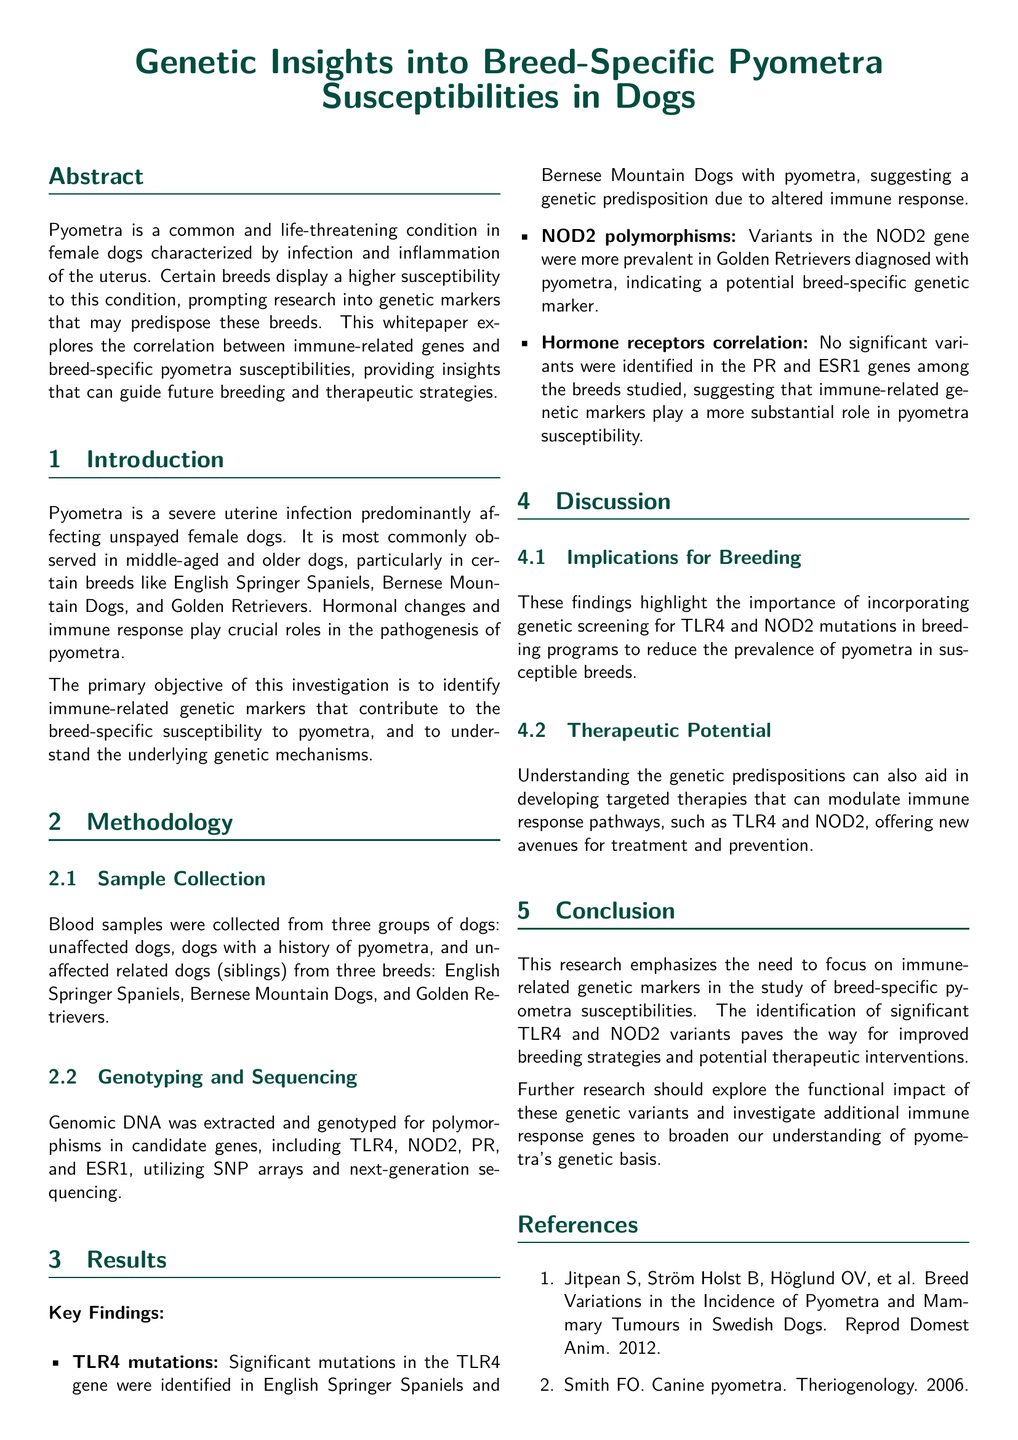What is the condition characterized by infection and inflammation of the uterus? The document describes pyometra as the common condition affecting female dogs characterized by infection and inflammation of the uterus.
Answer: Pyometra Which breeds are specifically mentioned as having a higher susceptibility to pyometra? The breeds highlighted for their higher susceptibility to pyometra are English Springer Spaniels, Bernese Mountain Dogs, and Golden Retrievers.
Answer: English Springer Spaniels, Bernese Mountain Dogs, Golden Retrievers What are the two immune-related genes identified with significant mutations associated with pyometra? The key findings mention TLR4 and NOD2 genes with significant mutations linked to pyometra susceptibility in certain breeds.
Answer: TLR4, NOD2 What type of genetic variations were found in Golden Retrievers diagnosed with pyometra? The results state that variants in the NOD2 gene were more prevalent among Golden Retrievers with pyometra, indicating its role as a potential genetic marker.
Answer: Variants in the NOD2 gene What does the research imply about the genetic screening of certain mutations? The discussion highlights that the findings support incorporating genetic screening for TLR4 and NOD2 mutations in breeding programs to reduce pyometra prevalence.
Answer: Genetic screening for TLR4 and NOD2 mutations What is the primary objective of the investigation? The primary objective outlined in the introduction is to identify immune-related genetic markers that contribute to the breed-specific susceptibility to pyometra.
Answer: Identify immune-related genetic markers What does TLR4 stand for? The document does not explicitly define abbreviations, but TLR4 is known in the context as Toll-Like Receptor 4, associated with immune response.
Answer: Toll-Like Receptor 4 What method was used for genomic DNA extraction? The methodology section briefly describes that genomic DNA was extracted, but does not specify the method. However, the process generally involves various laboratory techniques.
Answer: Not specified Which year was the paper by Brookshire et al. published? The references section lists the publication year for the paper by Brookshire et al. as 2020.
Answer: 2020 